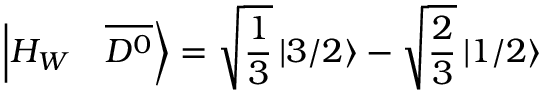Convert formula to latex. <formula><loc_0><loc_0><loc_500><loc_500>\left | H _ { W } \quad \overline { { { D ^ { 0 } } } } \right \rangle = \sqrt { \frac { 1 } { 3 } } \left | 3 / 2 \right \rangle - \sqrt { \frac { 2 } { 3 } } \left | 1 / 2 \right \rangle</formula> 